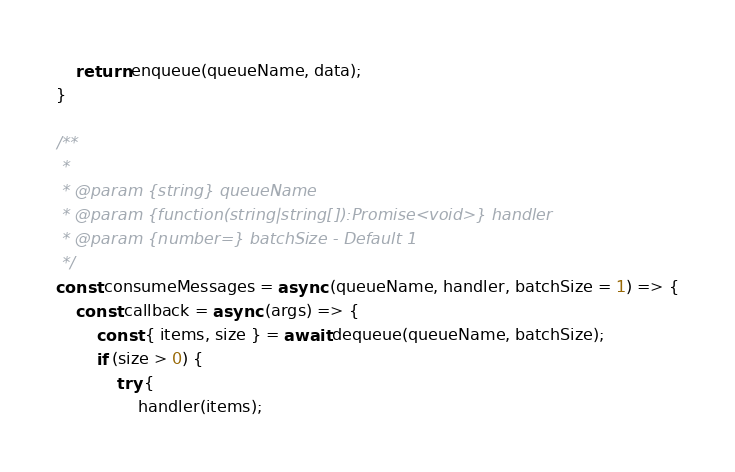Convert code to text. <code><loc_0><loc_0><loc_500><loc_500><_JavaScript_>    return enqueue(queueName, data);
}

/**
 * 
 * @param {string} queueName
 * @param {function(string|string[]):Promise<void>} handler
 * @param {number=} batchSize - Default 1
 */
const consumeMessages = async (queueName, handler, batchSize = 1) => {
    const callback = async (args) => {
        const { items, size } = await dequeue(queueName, batchSize);
        if (size > 0) {
            try {
                handler(items);</code> 